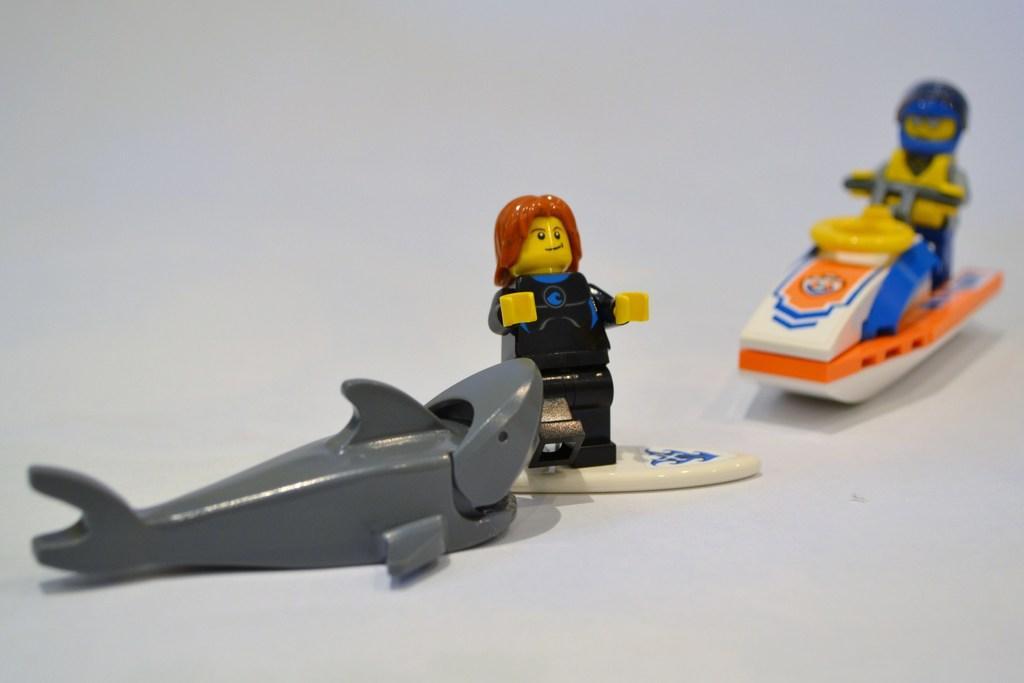Please provide a concise description of this image. In this image there are three toys, in which there is a shark , a person standing on the surfboard, a person sitting on a motor boat. 